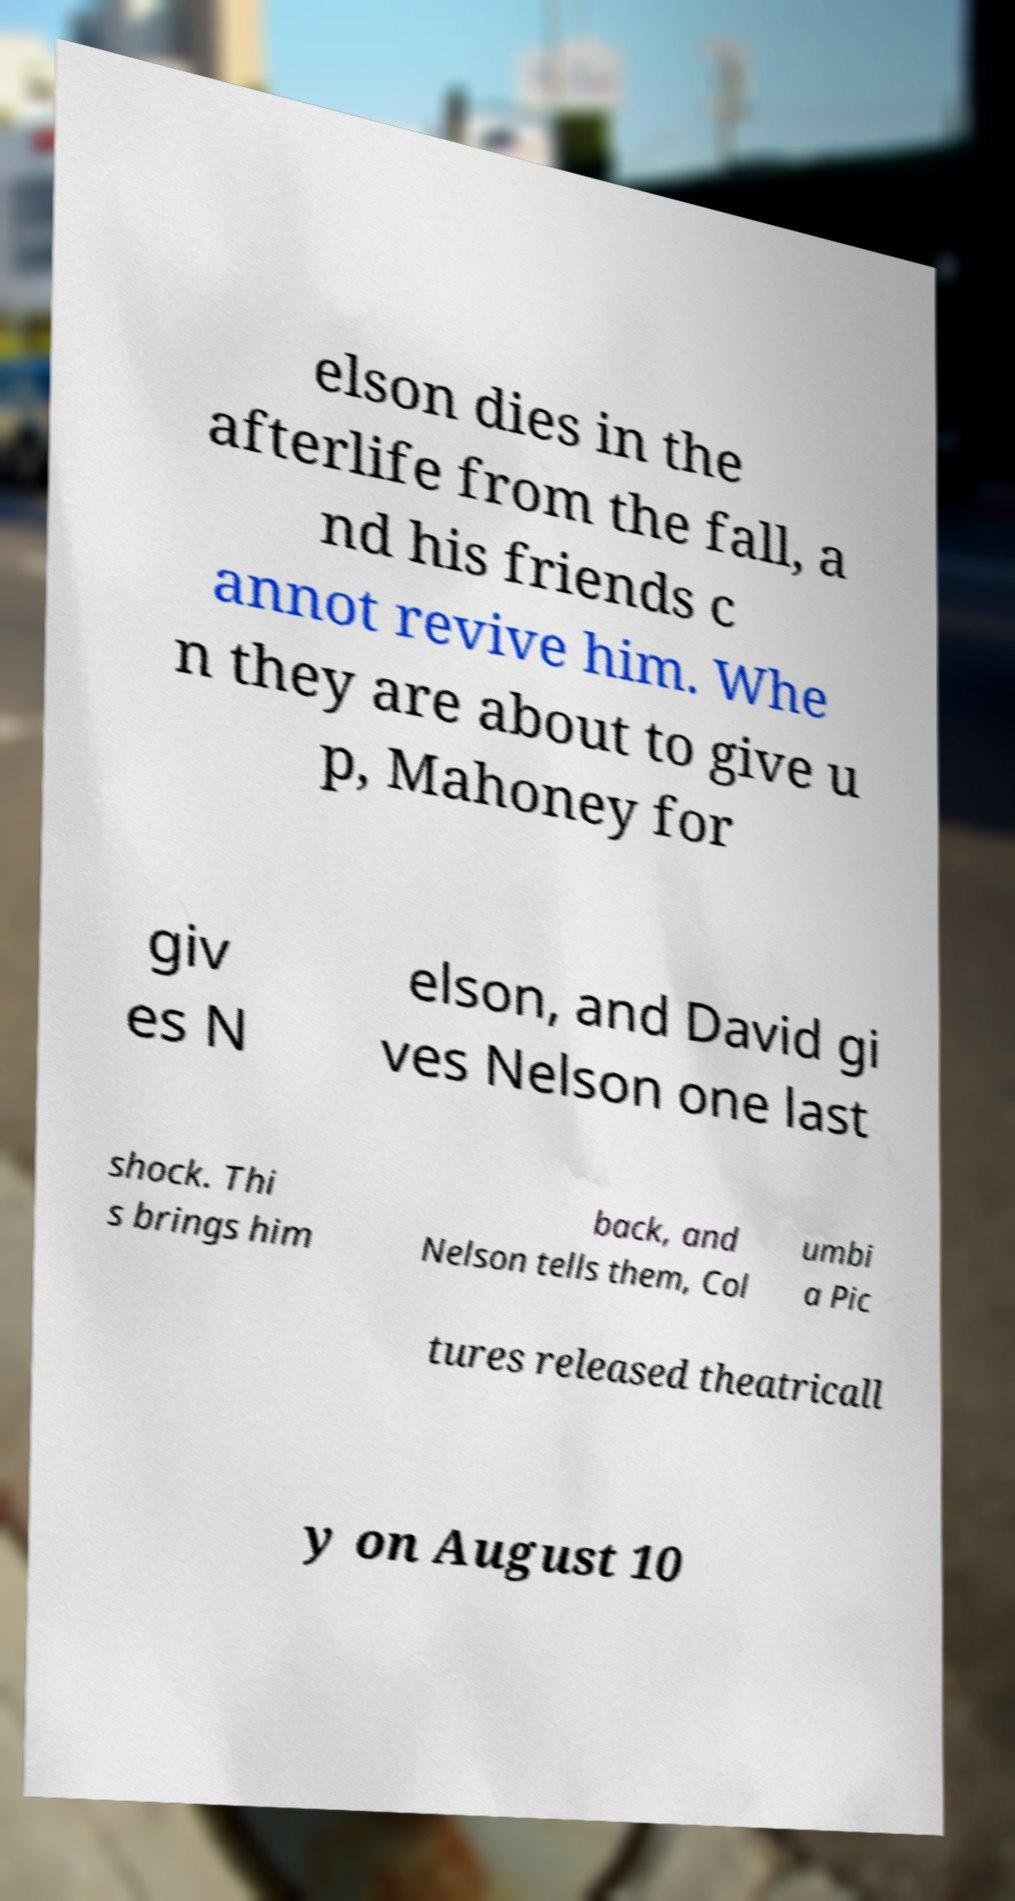Please identify and transcribe the text found in this image. elson dies in the afterlife from the fall, a nd his friends c annot revive him. Whe n they are about to give u p, Mahoney for giv es N elson, and David gi ves Nelson one last shock. Thi s brings him back, and Nelson tells them, Col umbi a Pic tures released theatricall y on August 10 